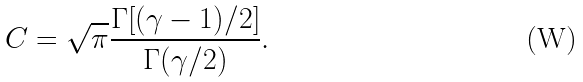Convert formula to latex. <formula><loc_0><loc_0><loc_500><loc_500>C = \sqrt { \pi } \frac { \Gamma [ ( \gamma - 1 ) / 2 ] } { \Gamma ( \gamma / 2 ) } .</formula> 